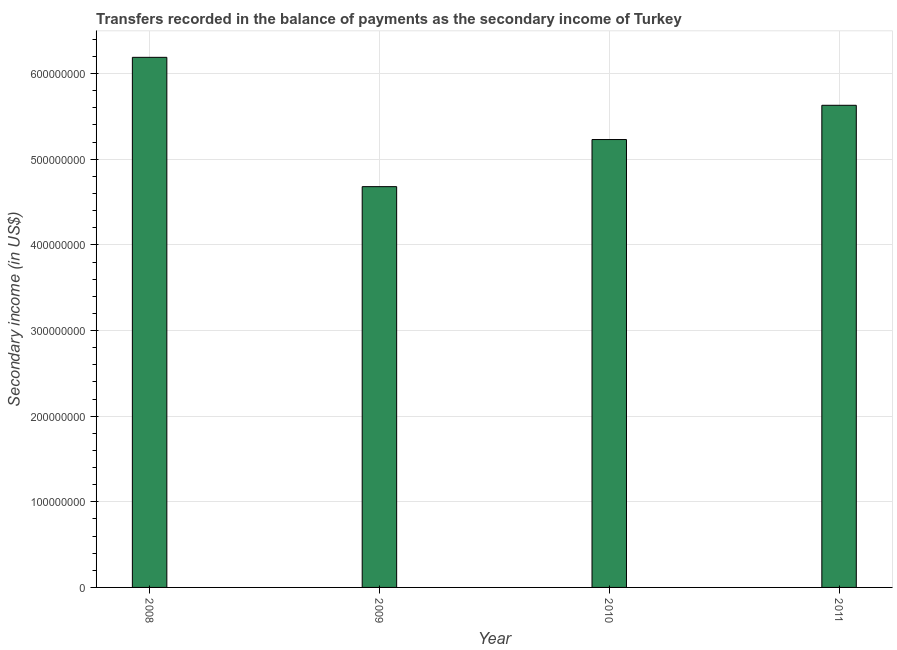Does the graph contain grids?
Provide a succinct answer. Yes. What is the title of the graph?
Keep it short and to the point. Transfers recorded in the balance of payments as the secondary income of Turkey. What is the label or title of the Y-axis?
Your answer should be compact. Secondary income (in US$). What is the amount of secondary income in 2010?
Provide a succinct answer. 5.23e+08. Across all years, what is the maximum amount of secondary income?
Offer a terse response. 6.19e+08. Across all years, what is the minimum amount of secondary income?
Make the answer very short. 4.68e+08. In which year was the amount of secondary income maximum?
Your answer should be compact. 2008. In which year was the amount of secondary income minimum?
Give a very brief answer. 2009. What is the sum of the amount of secondary income?
Make the answer very short. 2.17e+09. What is the difference between the amount of secondary income in 2008 and 2011?
Keep it short and to the point. 5.60e+07. What is the average amount of secondary income per year?
Keep it short and to the point. 5.43e+08. What is the median amount of secondary income?
Provide a short and direct response. 5.43e+08. Do a majority of the years between 2008 and 2010 (inclusive) have amount of secondary income greater than 420000000 US$?
Give a very brief answer. Yes. What is the ratio of the amount of secondary income in 2009 to that in 2010?
Your answer should be compact. 0.9. Is the amount of secondary income in 2008 less than that in 2009?
Your response must be concise. No. What is the difference between the highest and the second highest amount of secondary income?
Your response must be concise. 5.60e+07. Is the sum of the amount of secondary income in 2010 and 2011 greater than the maximum amount of secondary income across all years?
Your answer should be very brief. Yes. What is the difference between the highest and the lowest amount of secondary income?
Your answer should be very brief. 1.51e+08. In how many years, is the amount of secondary income greater than the average amount of secondary income taken over all years?
Keep it short and to the point. 2. Are all the bars in the graph horizontal?
Provide a succinct answer. No. How many years are there in the graph?
Your answer should be very brief. 4. What is the difference between two consecutive major ticks on the Y-axis?
Ensure brevity in your answer.  1.00e+08. Are the values on the major ticks of Y-axis written in scientific E-notation?
Provide a succinct answer. No. What is the Secondary income (in US$) of 2008?
Offer a very short reply. 6.19e+08. What is the Secondary income (in US$) in 2009?
Your answer should be very brief. 4.68e+08. What is the Secondary income (in US$) of 2010?
Offer a terse response. 5.23e+08. What is the Secondary income (in US$) in 2011?
Ensure brevity in your answer.  5.63e+08. What is the difference between the Secondary income (in US$) in 2008 and 2009?
Give a very brief answer. 1.51e+08. What is the difference between the Secondary income (in US$) in 2008 and 2010?
Keep it short and to the point. 9.60e+07. What is the difference between the Secondary income (in US$) in 2008 and 2011?
Provide a short and direct response. 5.60e+07. What is the difference between the Secondary income (in US$) in 2009 and 2010?
Give a very brief answer. -5.50e+07. What is the difference between the Secondary income (in US$) in 2009 and 2011?
Your answer should be very brief. -9.50e+07. What is the difference between the Secondary income (in US$) in 2010 and 2011?
Offer a terse response. -4.00e+07. What is the ratio of the Secondary income (in US$) in 2008 to that in 2009?
Provide a short and direct response. 1.32. What is the ratio of the Secondary income (in US$) in 2008 to that in 2010?
Offer a very short reply. 1.18. What is the ratio of the Secondary income (in US$) in 2008 to that in 2011?
Keep it short and to the point. 1.1. What is the ratio of the Secondary income (in US$) in 2009 to that in 2010?
Offer a very short reply. 0.9. What is the ratio of the Secondary income (in US$) in 2009 to that in 2011?
Make the answer very short. 0.83. What is the ratio of the Secondary income (in US$) in 2010 to that in 2011?
Offer a terse response. 0.93. 